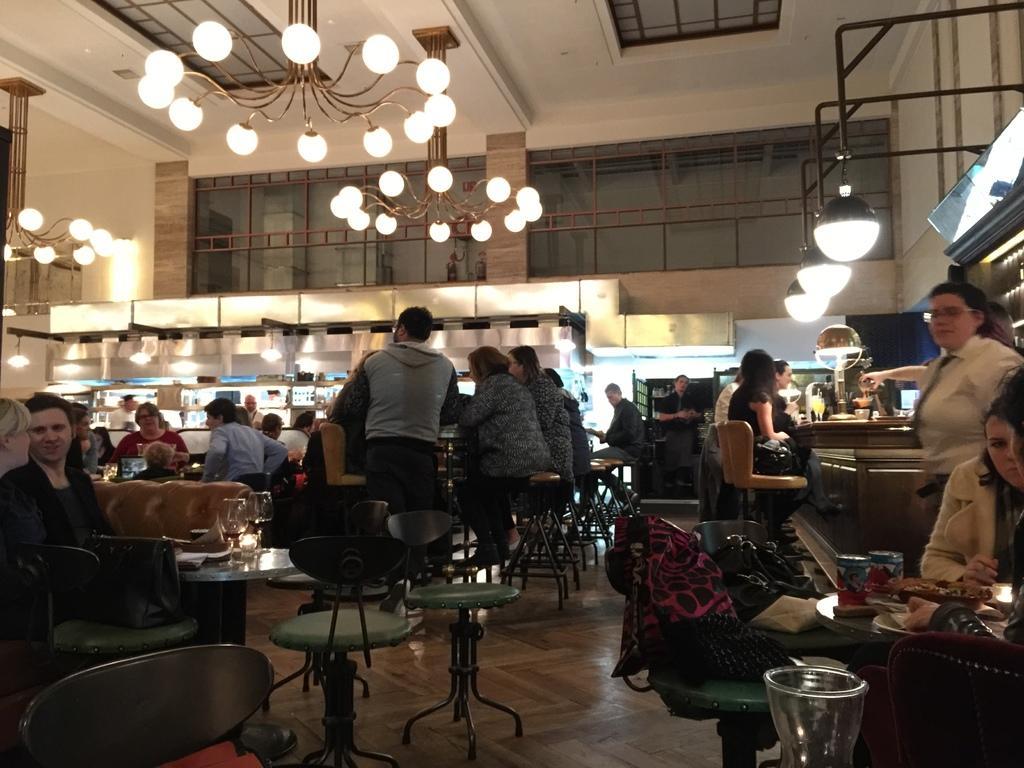Please provide a concise description of this image. In this picture we can observe some people standing and some of them were sitting in the chairs around the table. There were women and men in this picture. We can observe chandeliers. In the background there is a wall and some lights. 